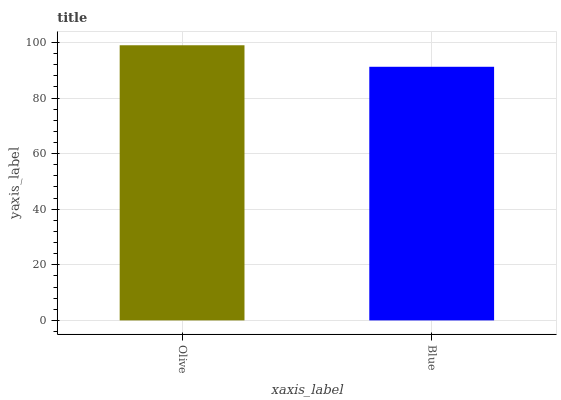Is Blue the minimum?
Answer yes or no. Yes. Is Olive the maximum?
Answer yes or no. Yes. Is Blue the maximum?
Answer yes or no. No. Is Olive greater than Blue?
Answer yes or no. Yes. Is Blue less than Olive?
Answer yes or no. Yes. Is Blue greater than Olive?
Answer yes or no. No. Is Olive less than Blue?
Answer yes or no. No. Is Olive the high median?
Answer yes or no. Yes. Is Blue the low median?
Answer yes or no. Yes. Is Blue the high median?
Answer yes or no. No. Is Olive the low median?
Answer yes or no. No. 